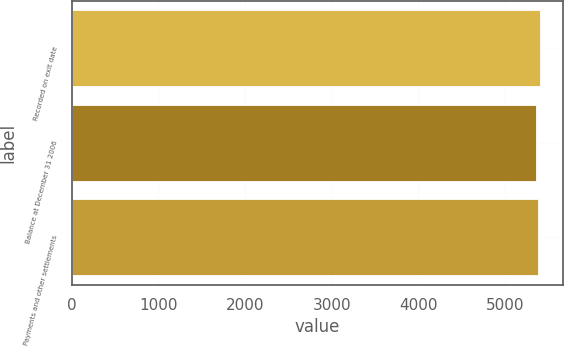Convert chart. <chart><loc_0><loc_0><loc_500><loc_500><bar_chart><fcel>Recorded on exit date<fcel>Balance at December 31 2006<fcel>Payments and other settlements<nl><fcel>5401<fcel>5358<fcel>5379<nl></chart> 